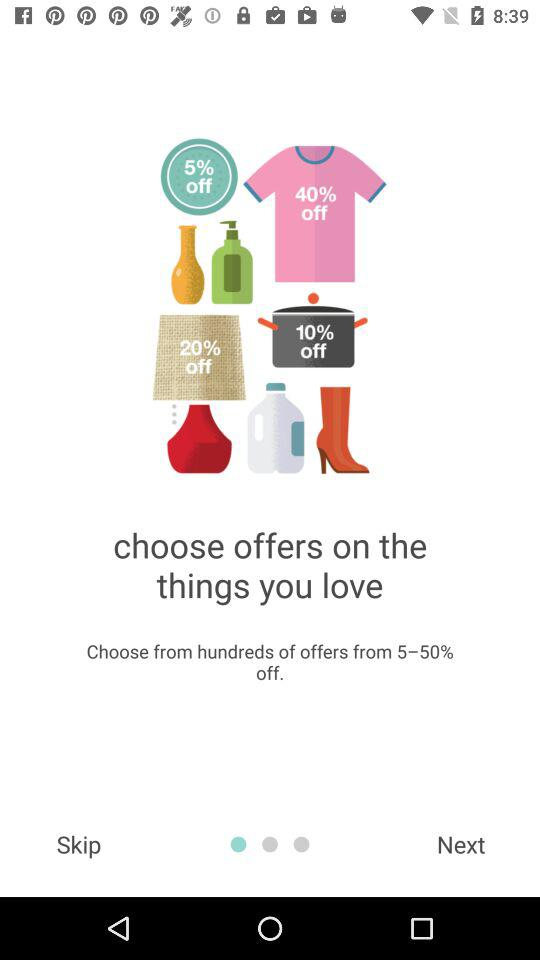What is the percentage range of the offers?
Answer the question using a single word or phrase. 5-50% 